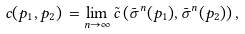<formula> <loc_0><loc_0><loc_500><loc_500>c ( p _ { 1 } , p _ { 2 } ) \, = \lim _ { n \to \infty } \tilde { c } \left ( \bar { \sigma } ^ { n } ( p _ { 1 } ) , \bar { \sigma } ^ { n } ( p _ { 2 } ) \right ) ,</formula> 